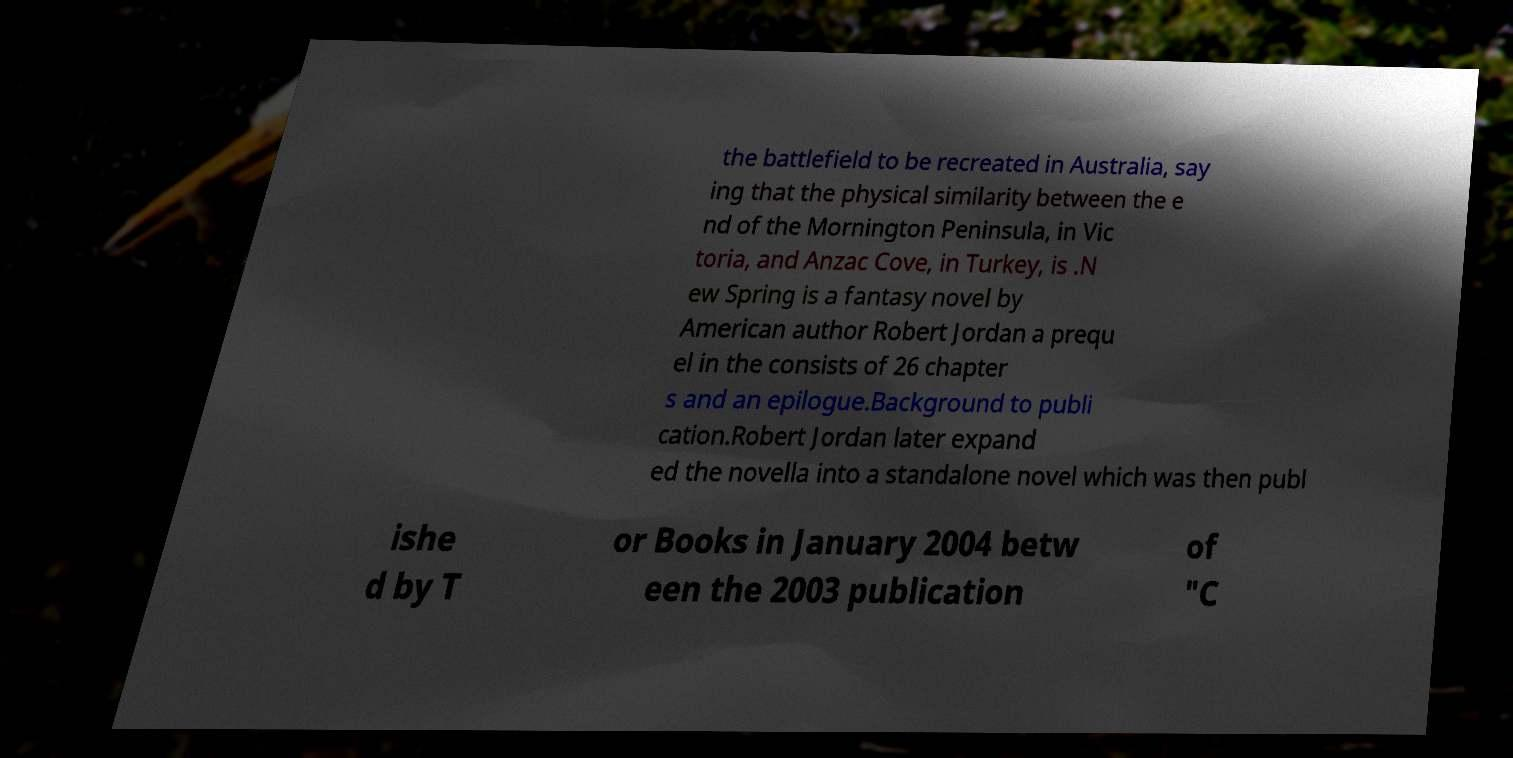For documentation purposes, I need the text within this image transcribed. Could you provide that? the battlefield to be recreated in Australia, say ing that the physical similarity between the e nd of the Mornington Peninsula, in Vic toria, and Anzac Cove, in Turkey, is .N ew Spring is a fantasy novel by American author Robert Jordan a prequ el in the consists of 26 chapter s and an epilogue.Background to publi cation.Robert Jordan later expand ed the novella into a standalone novel which was then publ ishe d by T or Books in January 2004 betw een the 2003 publication of "C 